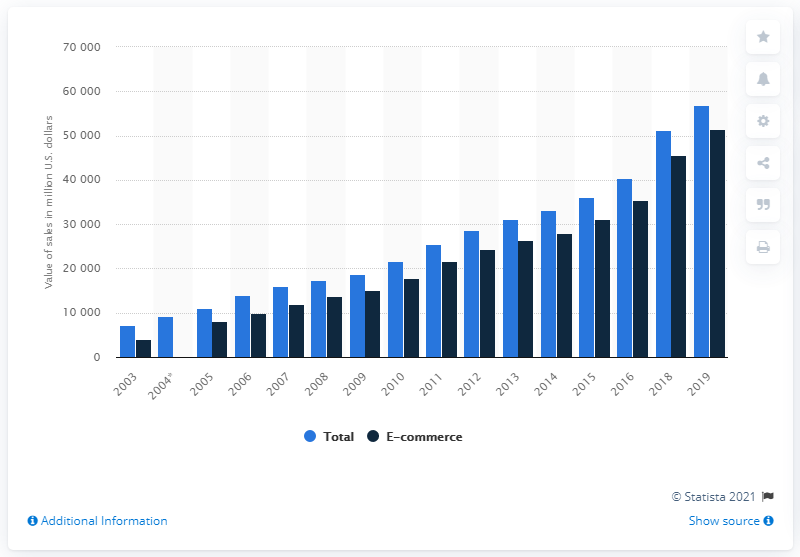Mention a couple of crucial points in this snapshot. The sales figures for electronics and appliances of electronic shopping and mail-order houses began in 2003. In 2016, the value of electronics and appliances e-commerce sales amounted to 35,471. In 2019, the value of electronics and appliances e-commerce sales was approximately 51,482. 